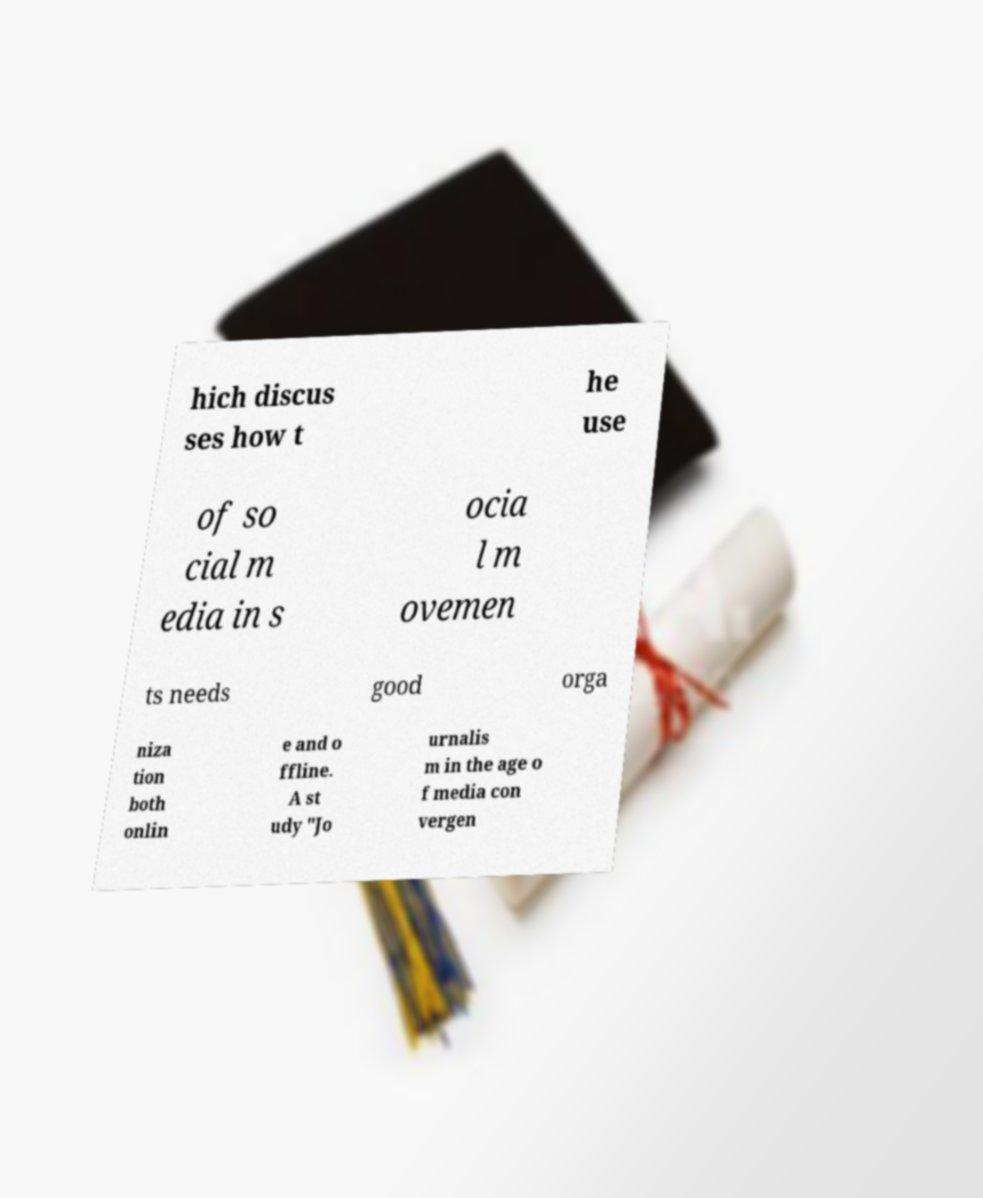Could you extract and type out the text from this image? hich discus ses how t he use of so cial m edia in s ocia l m ovemen ts needs good orga niza tion both onlin e and o ffline. A st udy "Jo urnalis m in the age o f media con vergen 